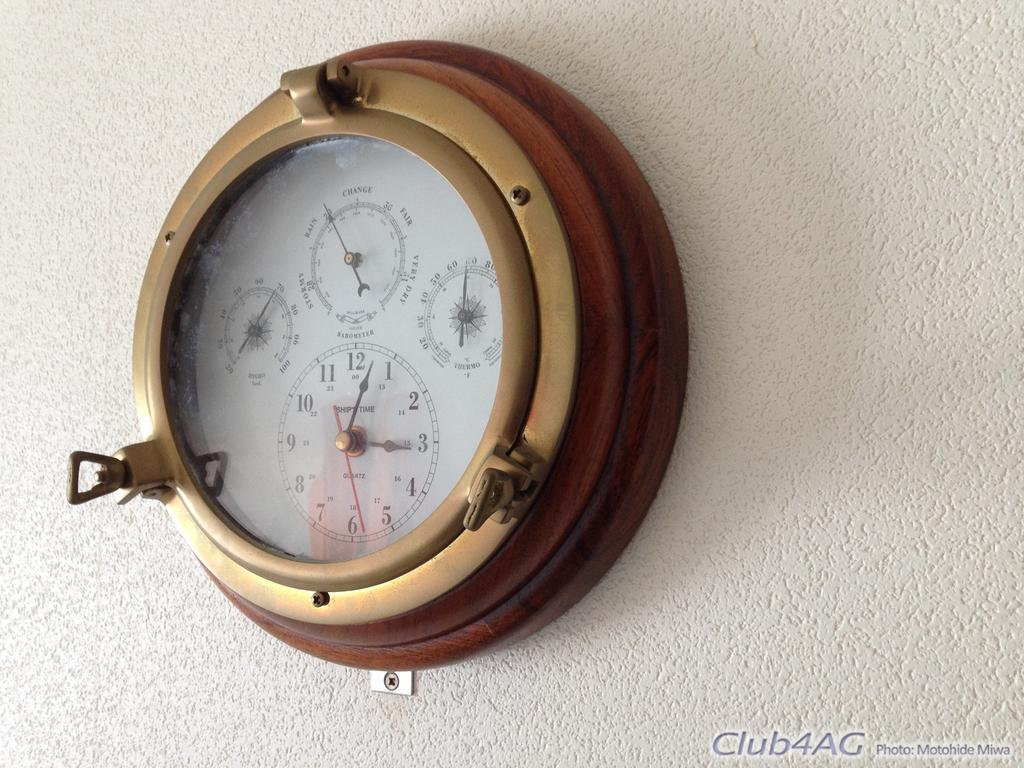<image>
Relay a brief, clear account of the picture shown. A barometer hanging on the wall with ship time pointing to 3:03 